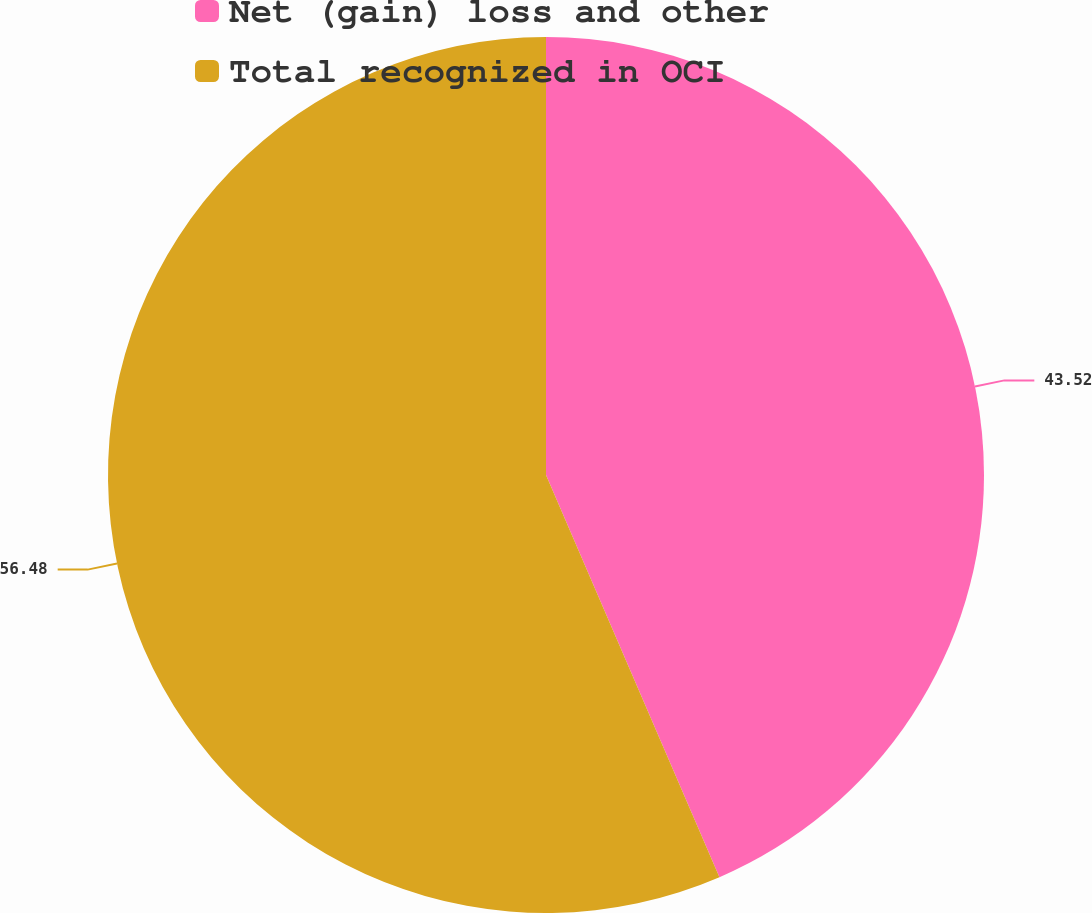Convert chart to OTSL. <chart><loc_0><loc_0><loc_500><loc_500><pie_chart><fcel>Net (gain) loss and other<fcel>Total recognized in OCI<nl><fcel>43.52%<fcel>56.48%<nl></chart> 